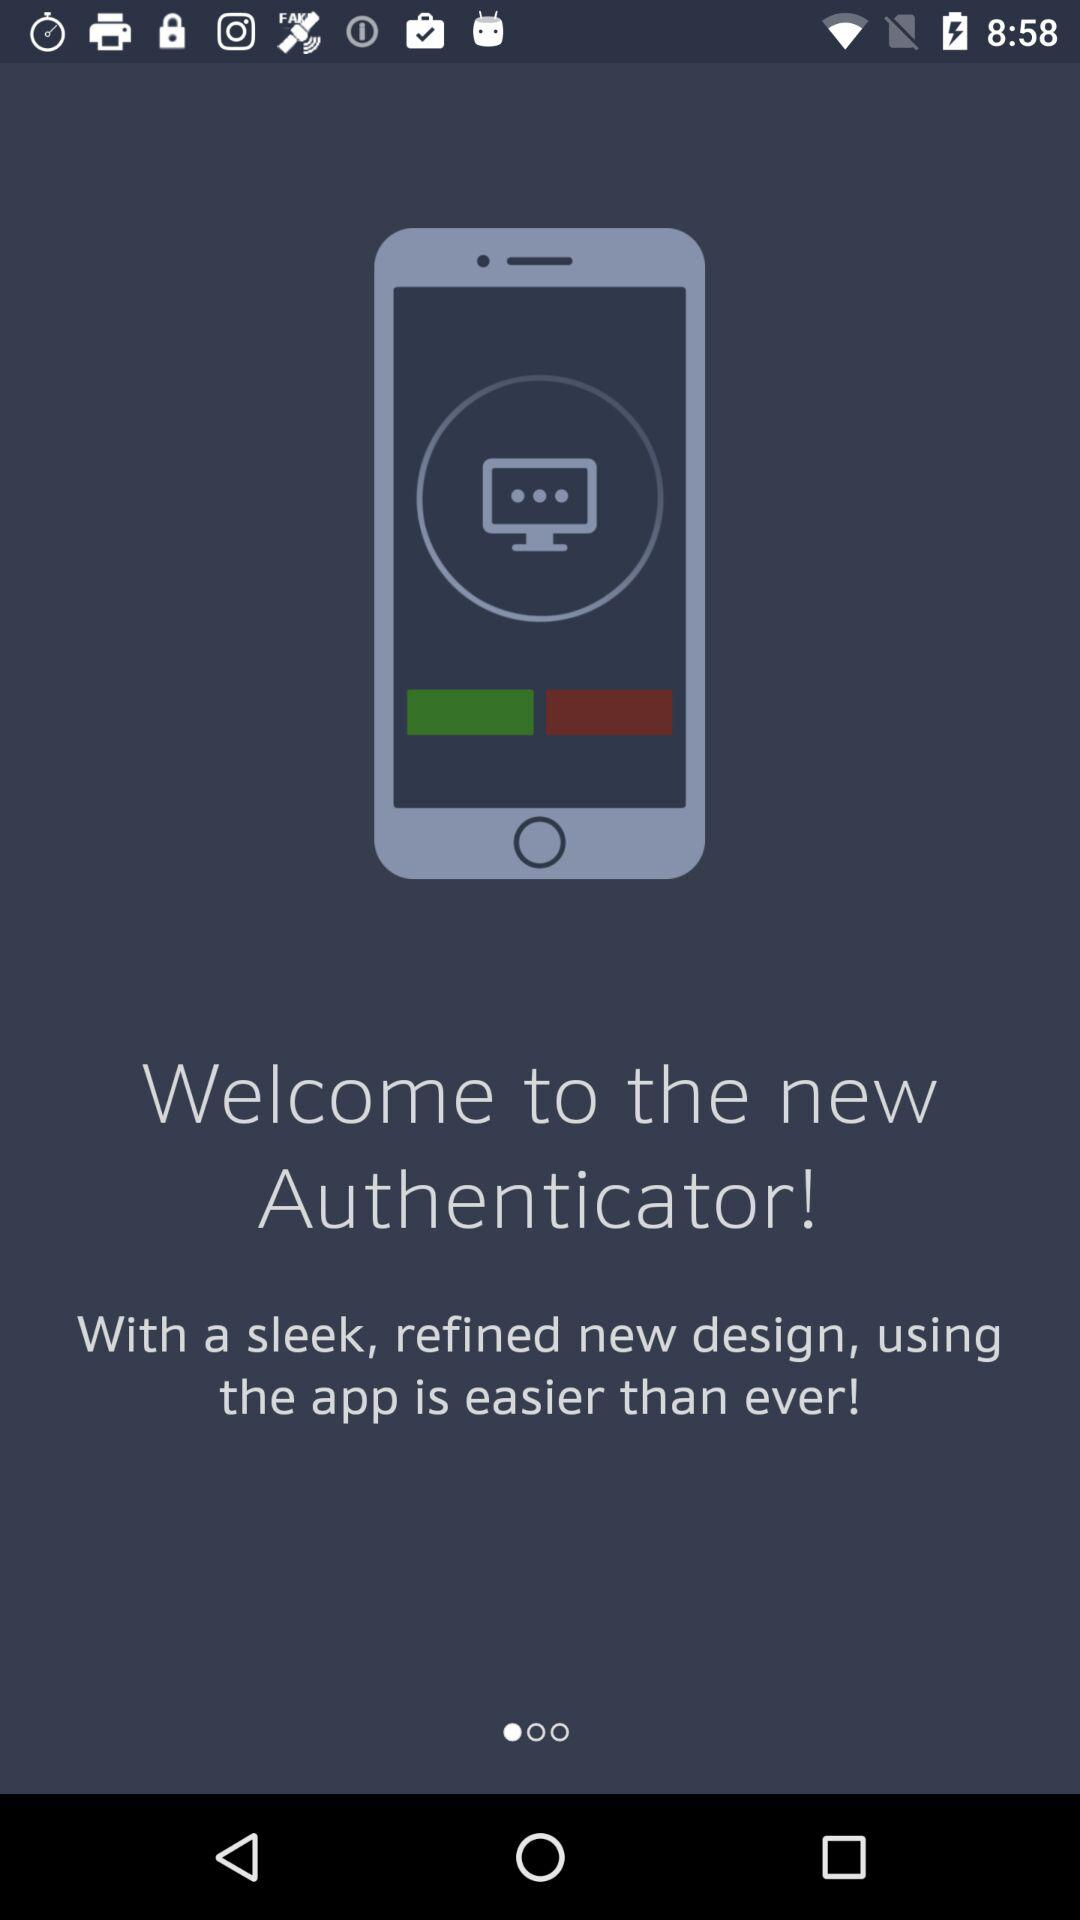What is the application name? The application name is "the new Authenticator". 